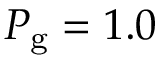Convert formula to latex. <formula><loc_0><loc_0><loc_500><loc_500>P _ { g } = 1 . 0</formula> 